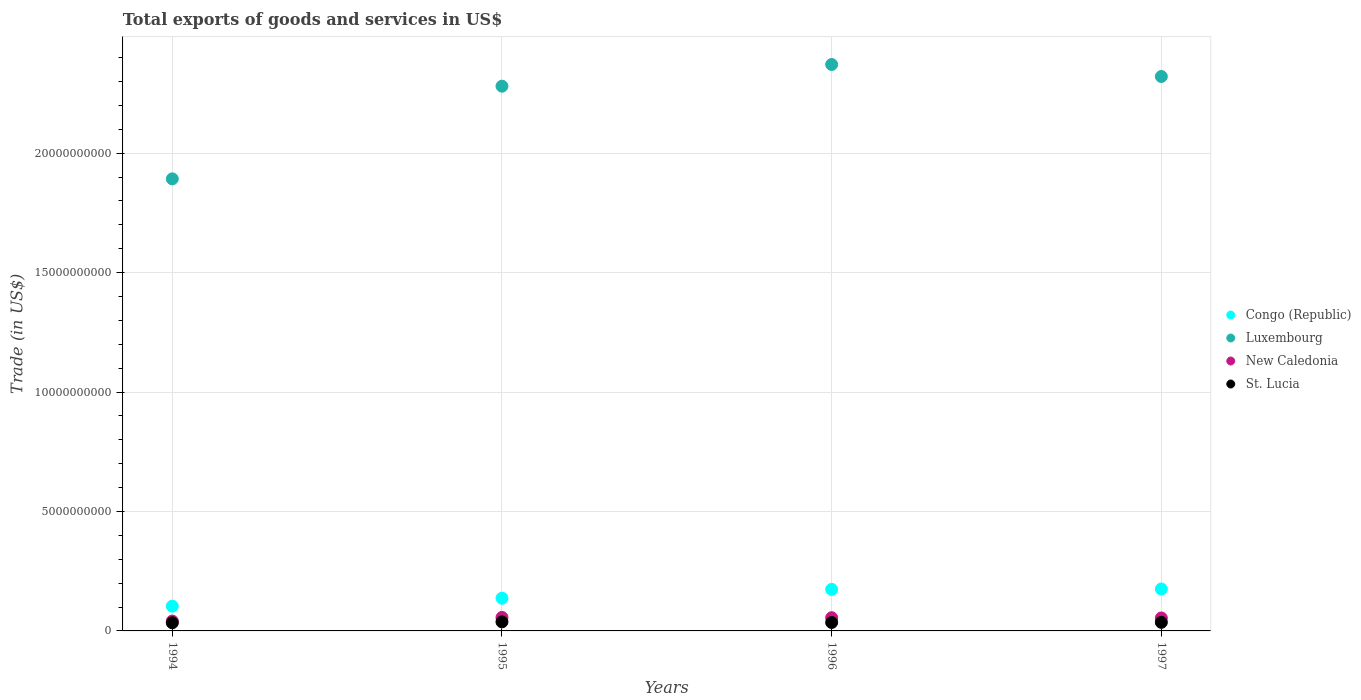What is the total exports of goods and services in St. Lucia in 1996?
Provide a succinct answer. 3.53e+08. Across all years, what is the maximum total exports of goods and services in St. Lucia?
Offer a terse response. 3.79e+08. Across all years, what is the minimum total exports of goods and services in Luxembourg?
Make the answer very short. 1.89e+1. What is the total total exports of goods and services in St. Lucia in the graph?
Offer a terse response. 1.43e+09. What is the difference between the total exports of goods and services in Luxembourg in 1995 and that in 1996?
Your response must be concise. -9.08e+08. What is the difference between the total exports of goods and services in St. Lucia in 1994 and the total exports of goods and services in Luxembourg in 1995?
Your answer should be compact. -2.25e+1. What is the average total exports of goods and services in Congo (Republic) per year?
Your answer should be compact. 1.47e+09. In the year 1994, what is the difference between the total exports of goods and services in Luxembourg and total exports of goods and services in St. Lucia?
Your answer should be very brief. 1.86e+1. In how many years, is the total exports of goods and services in Congo (Republic) greater than 14000000000 US$?
Provide a succinct answer. 0. What is the ratio of the total exports of goods and services in St. Lucia in 1994 to that in 1996?
Your answer should be compact. 0.96. Is the total exports of goods and services in St. Lucia in 1994 less than that in 1996?
Ensure brevity in your answer.  Yes. Is the difference between the total exports of goods and services in Luxembourg in 1994 and 1995 greater than the difference between the total exports of goods and services in St. Lucia in 1994 and 1995?
Provide a short and direct response. No. What is the difference between the highest and the second highest total exports of goods and services in Luxembourg?
Provide a succinct answer. 5.03e+08. What is the difference between the highest and the lowest total exports of goods and services in New Caledonia?
Give a very brief answer. 1.52e+08. Is the sum of the total exports of goods and services in Congo (Republic) in 1996 and 1997 greater than the maximum total exports of goods and services in St. Lucia across all years?
Offer a very short reply. Yes. Is it the case that in every year, the sum of the total exports of goods and services in New Caledonia and total exports of goods and services in Congo (Republic)  is greater than the sum of total exports of goods and services in St. Lucia and total exports of goods and services in Luxembourg?
Make the answer very short. Yes. Is the total exports of goods and services in St. Lucia strictly less than the total exports of goods and services in Luxembourg over the years?
Provide a short and direct response. Yes. What is the difference between two consecutive major ticks on the Y-axis?
Keep it short and to the point. 5.00e+09. Does the graph contain any zero values?
Ensure brevity in your answer.  No. How are the legend labels stacked?
Provide a succinct answer. Vertical. What is the title of the graph?
Your answer should be very brief. Total exports of goods and services in US$. What is the label or title of the X-axis?
Offer a terse response. Years. What is the label or title of the Y-axis?
Offer a terse response. Trade (in US$). What is the Trade (in US$) in Congo (Republic) in 1994?
Give a very brief answer. 1.04e+09. What is the Trade (in US$) in Luxembourg in 1994?
Your answer should be compact. 1.89e+1. What is the Trade (in US$) in New Caledonia in 1994?
Your answer should be very brief. 4.13e+08. What is the Trade (in US$) of St. Lucia in 1994?
Your response must be concise. 3.40e+08. What is the Trade (in US$) of Congo (Republic) in 1995?
Make the answer very short. 1.37e+09. What is the Trade (in US$) in Luxembourg in 1995?
Your answer should be very brief. 2.28e+1. What is the Trade (in US$) of New Caledonia in 1995?
Keep it short and to the point. 5.65e+08. What is the Trade (in US$) in St. Lucia in 1995?
Offer a terse response. 3.79e+08. What is the Trade (in US$) in Congo (Republic) in 1996?
Ensure brevity in your answer.  1.74e+09. What is the Trade (in US$) of Luxembourg in 1996?
Offer a very short reply. 2.37e+1. What is the Trade (in US$) of New Caledonia in 1996?
Ensure brevity in your answer.  5.54e+08. What is the Trade (in US$) of St. Lucia in 1996?
Offer a very short reply. 3.53e+08. What is the Trade (in US$) of Congo (Republic) in 1997?
Offer a terse response. 1.76e+09. What is the Trade (in US$) in Luxembourg in 1997?
Offer a terse response. 2.32e+1. What is the Trade (in US$) in New Caledonia in 1997?
Your answer should be compact. 5.43e+08. What is the Trade (in US$) in St. Lucia in 1997?
Provide a succinct answer. 3.59e+08. Across all years, what is the maximum Trade (in US$) of Congo (Republic)?
Give a very brief answer. 1.76e+09. Across all years, what is the maximum Trade (in US$) of Luxembourg?
Provide a succinct answer. 2.37e+1. Across all years, what is the maximum Trade (in US$) of New Caledonia?
Give a very brief answer. 5.65e+08. Across all years, what is the maximum Trade (in US$) in St. Lucia?
Offer a terse response. 3.79e+08. Across all years, what is the minimum Trade (in US$) in Congo (Republic)?
Provide a succinct answer. 1.04e+09. Across all years, what is the minimum Trade (in US$) in Luxembourg?
Your response must be concise. 1.89e+1. Across all years, what is the minimum Trade (in US$) in New Caledonia?
Offer a terse response. 4.13e+08. Across all years, what is the minimum Trade (in US$) of St. Lucia?
Keep it short and to the point. 3.40e+08. What is the total Trade (in US$) of Congo (Republic) in the graph?
Your answer should be compact. 5.90e+09. What is the total Trade (in US$) of Luxembourg in the graph?
Ensure brevity in your answer.  8.87e+1. What is the total Trade (in US$) of New Caledonia in the graph?
Provide a succinct answer. 2.07e+09. What is the total Trade (in US$) of St. Lucia in the graph?
Provide a short and direct response. 1.43e+09. What is the difference between the Trade (in US$) in Congo (Republic) in 1994 and that in 1995?
Keep it short and to the point. -3.34e+08. What is the difference between the Trade (in US$) in Luxembourg in 1994 and that in 1995?
Provide a succinct answer. -3.88e+09. What is the difference between the Trade (in US$) of New Caledonia in 1994 and that in 1995?
Your answer should be very brief. -1.52e+08. What is the difference between the Trade (in US$) of St. Lucia in 1994 and that in 1995?
Provide a succinct answer. -3.88e+07. What is the difference between the Trade (in US$) of Congo (Republic) in 1994 and that in 1996?
Your answer should be very brief. -7.04e+08. What is the difference between the Trade (in US$) in Luxembourg in 1994 and that in 1996?
Offer a terse response. -4.79e+09. What is the difference between the Trade (in US$) of New Caledonia in 1994 and that in 1996?
Your answer should be very brief. -1.40e+08. What is the difference between the Trade (in US$) in St. Lucia in 1994 and that in 1996?
Provide a short and direct response. -1.31e+07. What is the difference between the Trade (in US$) of Congo (Republic) in 1994 and that in 1997?
Keep it short and to the point. -7.21e+08. What is the difference between the Trade (in US$) in Luxembourg in 1994 and that in 1997?
Make the answer very short. -4.29e+09. What is the difference between the Trade (in US$) of New Caledonia in 1994 and that in 1997?
Provide a succinct answer. -1.30e+08. What is the difference between the Trade (in US$) of St. Lucia in 1994 and that in 1997?
Your answer should be very brief. -1.87e+07. What is the difference between the Trade (in US$) in Congo (Republic) in 1995 and that in 1996?
Your response must be concise. -3.70e+08. What is the difference between the Trade (in US$) of Luxembourg in 1995 and that in 1996?
Give a very brief answer. -9.08e+08. What is the difference between the Trade (in US$) of New Caledonia in 1995 and that in 1996?
Your response must be concise. 1.12e+07. What is the difference between the Trade (in US$) of St. Lucia in 1995 and that in 1996?
Ensure brevity in your answer.  2.57e+07. What is the difference between the Trade (in US$) in Congo (Republic) in 1995 and that in 1997?
Offer a terse response. -3.87e+08. What is the difference between the Trade (in US$) in Luxembourg in 1995 and that in 1997?
Ensure brevity in your answer.  -4.06e+08. What is the difference between the Trade (in US$) of New Caledonia in 1995 and that in 1997?
Ensure brevity in your answer.  2.19e+07. What is the difference between the Trade (in US$) of St. Lucia in 1995 and that in 1997?
Provide a short and direct response. 2.01e+07. What is the difference between the Trade (in US$) in Congo (Republic) in 1996 and that in 1997?
Provide a short and direct response. -1.66e+07. What is the difference between the Trade (in US$) of Luxembourg in 1996 and that in 1997?
Provide a short and direct response. 5.03e+08. What is the difference between the Trade (in US$) of New Caledonia in 1996 and that in 1997?
Your response must be concise. 1.07e+07. What is the difference between the Trade (in US$) in St. Lucia in 1996 and that in 1997?
Provide a succinct answer. -5.56e+06. What is the difference between the Trade (in US$) of Congo (Republic) in 1994 and the Trade (in US$) of Luxembourg in 1995?
Your answer should be very brief. -2.18e+1. What is the difference between the Trade (in US$) in Congo (Republic) in 1994 and the Trade (in US$) in New Caledonia in 1995?
Provide a succinct answer. 4.71e+08. What is the difference between the Trade (in US$) of Congo (Republic) in 1994 and the Trade (in US$) of St. Lucia in 1995?
Provide a short and direct response. 6.57e+08. What is the difference between the Trade (in US$) of Luxembourg in 1994 and the Trade (in US$) of New Caledonia in 1995?
Offer a very short reply. 1.84e+1. What is the difference between the Trade (in US$) in Luxembourg in 1994 and the Trade (in US$) in St. Lucia in 1995?
Your response must be concise. 1.85e+1. What is the difference between the Trade (in US$) in New Caledonia in 1994 and the Trade (in US$) in St. Lucia in 1995?
Offer a terse response. 3.44e+07. What is the difference between the Trade (in US$) of Congo (Republic) in 1994 and the Trade (in US$) of Luxembourg in 1996?
Offer a terse response. -2.27e+1. What is the difference between the Trade (in US$) of Congo (Republic) in 1994 and the Trade (in US$) of New Caledonia in 1996?
Keep it short and to the point. 4.82e+08. What is the difference between the Trade (in US$) of Congo (Republic) in 1994 and the Trade (in US$) of St. Lucia in 1996?
Ensure brevity in your answer.  6.82e+08. What is the difference between the Trade (in US$) in Luxembourg in 1994 and the Trade (in US$) in New Caledonia in 1996?
Make the answer very short. 1.84e+1. What is the difference between the Trade (in US$) of Luxembourg in 1994 and the Trade (in US$) of St. Lucia in 1996?
Keep it short and to the point. 1.86e+1. What is the difference between the Trade (in US$) of New Caledonia in 1994 and the Trade (in US$) of St. Lucia in 1996?
Provide a succinct answer. 6.00e+07. What is the difference between the Trade (in US$) in Congo (Republic) in 1994 and the Trade (in US$) in Luxembourg in 1997?
Your answer should be compact. -2.22e+1. What is the difference between the Trade (in US$) in Congo (Republic) in 1994 and the Trade (in US$) in New Caledonia in 1997?
Your response must be concise. 4.93e+08. What is the difference between the Trade (in US$) in Congo (Republic) in 1994 and the Trade (in US$) in St. Lucia in 1997?
Provide a short and direct response. 6.77e+08. What is the difference between the Trade (in US$) of Luxembourg in 1994 and the Trade (in US$) of New Caledonia in 1997?
Keep it short and to the point. 1.84e+1. What is the difference between the Trade (in US$) in Luxembourg in 1994 and the Trade (in US$) in St. Lucia in 1997?
Your answer should be compact. 1.86e+1. What is the difference between the Trade (in US$) in New Caledonia in 1994 and the Trade (in US$) in St. Lucia in 1997?
Give a very brief answer. 5.45e+07. What is the difference between the Trade (in US$) in Congo (Republic) in 1995 and the Trade (in US$) in Luxembourg in 1996?
Your answer should be compact. -2.23e+1. What is the difference between the Trade (in US$) of Congo (Republic) in 1995 and the Trade (in US$) of New Caledonia in 1996?
Offer a very short reply. 8.16e+08. What is the difference between the Trade (in US$) in Congo (Republic) in 1995 and the Trade (in US$) in St. Lucia in 1996?
Offer a very short reply. 1.02e+09. What is the difference between the Trade (in US$) of Luxembourg in 1995 and the Trade (in US$) of New Caledonia in 1996?
Your response must be concise. 2.23e+1. What is the difference between the Trade (in US$) of Luxembourg in 1995 and the Trade (in US$) of St. Lucia in 1996?
Make the answer very short. 2.25e+1. What is the difference between the Trade (in US$) of New Caledonia in 1995 and the Trade (in US$) of St. Lucia in 1996?
Provide a short and direct response. 2.12e+08. What is the difference between the Trade (in US$) of Congo (Republic) in 1995 and the Trade (in US$) of Luxembourg in 1997?
Your answer should be very brief. -2.18e+1. What is the difference between the Trade (in US$) in Congo (Republic) in 1995 and the Trade (in US$) in New Caledonia in 1997?
Your response must be concise. 8.26e+08. What is the difference between the Trade (in US$) of Congo (Republic) in 1995 and the Trade (in US$) of St. Lucia in 1997?
Make the answer very short. 1.01e+09. What is the difference between the Trade (in US$) in Luxembourg in 1995 and the Trade (in US$) in New Caledonia in 1997?
Offer a very short reply. 2.23e+1. What is the difference between the Trade (in US$) of Luxembourg in 1995 and the Trade (in US$) of St. Lucia in 1997?
Provide a short and direct response. 2.24e+1. What is the difference between the Trade (in US$) in New Caledonia in 1995 and the Trade (in US$) in St. Lucia in 1997?
Give a very brief answer. 2.06e+08. What is the difference between the Trade (in US$) in Congo (Republic) in 1996 and the Trade (in US$) in Luxembourg in 1997?
Your response must be concise. -2.15e+1. What is the difference between the Trade (in US$) of Congo (Republic) in 1996 and the Trade (in US$) of New Caledonia in 1997?
Your answer should be compact. 1.20e+09. What is the difference between the Trade (in US$) in Congo (Republic) in 1996 and the Trade (in US$) in St. Lucia in 1997?
Provide a succinct answer. 1.38e+09. What is the difference between the Trade (in US$) in Luxembourg in 1996 and the Trade (in US$) in New Caledonia in 1997?
Make the answer very short. 2.32e+1. What is the difference between the Trade (in US$) in Luxembourg in 1996 and the Trade (in US$) in St. Lucia in 1997?
Provide a short and direct response. 2.34e+1. What is the difference between the Trade (in US$) in New Caledonia in 1996 and the Trade (in US$) in St. Lucia in 1997?
Make the answer very short. 1.95e+08. What is the average Trade (in US$) in Congo (Republic) per year?
Offer a terse response. 1.47e+09. What is the average Trade (in US$) in Luxembourg per year?
Give a very brief answer. 2.22e+1. What is the average Trade (in US$) in New Caledonia per year?
Ensure brevity in your answer.  5.19e+08. What is the average Trade (in US$) of St. Lucia per year?
Provide a short and direct response. 3.58e+08. In the year 1994, what is the difference between the Trade (in US$) of Congo (Republic) and Trade (in US$) of Luxembourg?
Your response must be concise. -1.79e+1. In the year 1994, what is the difference between the Trade (in US$) in Congo (Republic) and Trade (in US$) in New Caledonia?
Ensure brevity in your answer.  6.22e+08. In the year 1994, what is the difference between the Trade (in US$) in Congo (Republic) and Trade (in US$) in St. Lucia?
Offer a terse response. 6.95e+08. In the year 1994, what is the difference between the Trade (in US$) in Luxembourg and Trade (in US$) in New Caledonia?
Give a very brief answer. 1.85e+1. In the year 1994, what is the difference between the Trade (in US$) of Luxembourg and Trade (in US$) of St. Lucia?
Your answer should be compact. 1.86e+1. In the year 1994, what is the difference between the Trade (in US$) of New Caledonia and Trade (in US$) of St. Lucia?
Your answer should be very brief. 7.32e+07. In the year 1995, what is the difference between the Trade (in US$) in Congo (Republic) and Trade (in US$) in Luxembourg?
Ensure brevity in your answer.  -2.14e+1. In the year 1995, what is the difference between the Trade (in US$) in Congo (Republic) and Trade (in US$) in New Caledonia?
Make the answer very short. 8.04e+08. In the year 1995, what is the difference between the Trade (in US$) of Congo (Republic) and Trade (in US$) of St. Lucia?
Offer a very short reply. 9.90e+08. In the year 1995, what is the difference between the Trade (in US$) in Luxembourg and Trade (in US$) in New Caledonia?
Provide a short and direct response. 2.22e+1. In the year 1995, what is the difference between the Trade (in US$) of Luxembourg and Trade (in US$) of St. Lucia?
Provide a succinct answer. 2.24e+1. In the year 1995, what is the difference between the Trade (in US$) of New Caledonia and Trade (in US$) of St. Lucia?
Provide a short and direct response. 1.86e+08. In the year 1996, what is the difference between the Trade (in US$) in Congo (Republic) and Trade (in US$) in Luxembourg?
Offer a terse response. -2.20e+1. In the year 1996, what is the difference between the Trade (in US$) of Congo (Republic) and Trade (in US$) of New Caledonia?
Keep it short and to the point. 1.19e+09. In the year 1996, what is the difference between the Trade (in US$) of Congo (Republic) and Trade (in US$) of St. Lucia?
Ensure brevity in your answer.  1.39e+09. In the year 1996, what is the difference between the Trade (in US$) of Luxembourg and Trade (in US$) of New Caledonia?
Ensure brevity in your answer.  2.32e+1. In the year 1996, what is the difference between the Trade (in US$) of Luxembourg and Trade (in US$) of St. Lucia?
Make the answer very short. 2.34e+1. In the year 1996, what is the difference between the Trade (in US$) of New Caledonia and Trade (in US$) of St. Lucia?
Keep it short and to the point. 2.00e+08. In the year 1997, what is the difference between the Trade (in US$) in Congo (Republic) and Trade (in US$) in Luxembourg?
Keep it short and to the point. -2.15e+1. In the year 1997, what is the difference between the Trade (in US$) of Congo (Republic) and Trade (in US$) of New Caledonia?
Offer a terse response. 1.21e+09. In the year 1997, what is the difference between the Trade (in US$) in Congo (Republic) and Trade (in US$) in St. Lucia?
Offer a very short reply. 1.40e+09. In the year 1997, what is the difference between the Trade (in US$) in Luxembourg and Trade (in US$) in New Caledonia?
Make the answer very short. 2.27e+1. In the year 1997, what is the difference between the Trade (in US$) in Luxembourg and Trade (in US$) in St. Lucia?
Offer a very short reply. 2.29e+1. In the year 1997, what is the difference between the Trade (in US$) of New Caledonia and Trade (in US$) of St. Lucia?
Ensure brevity in your answer.  1.84e+08. What is the ratio of the Trade (in US$) in Congo (Republic) in 1994 to that in 1995?
Your answer should be very brief. 0.76. What is the ratio of the Trade (in US$) of Luxembourg in 1994 to that in 1995?
Your answer should be very brief. 0.83. What is the ratio of the Trade (in US$) of New Caledonia in 1994 to that in 1995?
Provide a succinct answer. 0.73. What is the ratio of the Trade (in US$) of St. Lucia in 1994 to that in 1995?
Your response must be concise. 0.9. What is the ratio of the Trade (in US$) in Congo (Republic) in 1994 to that in 1996?
Your answer should be very brief. 0.6. What is the ratio of the Trade (in US$) in Luxembourg in 1994 to that in 1996?
Give a very brief answer. 0.8. What is the ratio of the Trade (in US$) of New Caledonia in 1994 to that in 1996?
Provide a succinct answer. 0.75. What is the ratio of the Trade (in US$) in St. Lucia in 1994 to that in 1996?
Make the answer very short. 0.96. What is the ratio of the Trade (in US$) in Congo (Republic) in 1994 to that in 1997?
Offer a terse response. 0.59. What is the ratio of the Trade (in US$) in Luxembourg in 1994 to that in 1997?
Ensure brevity in your answer.  0.82. What is the ratio of the Trade (in US$) in New Caledonia in 1994 to that in 1997?
Your response must be concise. 0.76. What is the ratio of the Trade (in US$) of St. Lucia in 1994 to that in 1997?
Make the answer very short. 0.95. What is the ratio of the Trade (in US$) in Congo (Republic) in 1995 to that in 1996?
Your response must be concise. 0.79. What is the ratio of the Trade (in US$) of Luxembourg in 1995 to that in 1996?
Your answer should be very brief. 0.96. What is the ratio of the Trade (in US$) of New Caledonia in 1995 to that in 1996?
Ensure brevity in your answer.  1.02. What is the ratio of the Trade (in US$) of St. Lucia in 1995 to that in 1996?
Give a very brief answer. 1.07. What is the ratio of the Trade (in US$) of Congo (Republic) in 1995 to that in 1997?
Your answer should be very brief. 0.78. What is the ratio of the Trade (in US$) in Luxembourg in 1995 to that in 1997?
Offer a very short reply. 0.98. What is the ratio of the Trade (in US$) in New Caledonia in 1995 to that in 1997?
Give a very brief answer. 1.04. What is the ratio of the Trade (in US$) of St. Lucia in 1995 to that in 1997?
Give a very brief answer. 1.06. What is the ratio of the Trade (in US$) of Congo (Republic) in 1996 to that in 1997?
Your answer should be very brief. 0.99. What is the ratio of the Trade (in US$) in Luxembourg in 1996 to that in 1997?
Your answer should be very brief. 1.02. What is the ratio of the Trade (in US$) of New Caledonia in 1996 to that in 1997?
Your answer should be very brief. 1.02. What is the ratio of the Trade (in US$) in St. Lucia in 1996 to that in 1997?
Offer a terse response. 0.98. What is the difference between the highest and the second highest Trade (in US$) of Congo (Republic)?
Offer a terse response. 1.66e+07. What is the difference between the highest and the second highest Trade (in US$) in Luxembourg?
Your answer should be compact. 5.03e+08. What is the difference between the highest and the second highest Trade (in US$) of New Caledonia?
Provide a short and direct response. 1.12e+07. What is the difference between the highest and the second highest Trade (in US$) of St. Lucia?
Your answer should be very brief. 2.01e+07. What is the difference between the highest and the lowest Trade (in US$) in Congo (Republic)?
Your response must be concise. 7.21e+08. What is the difference between the highest and the lowest Trade (in US$) of Luxembourg?
Offer a very short reply. 4.79e+09. What is the difference between the highest and the lowest Trade (in US$) of New Caledonia?
Ensure brevity in your answer.  1.52e+08. What is the difference between the highest and the lowest Trade (in US$) of St. Lucia?
Your answer should be compact. 3.88e+07. 